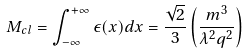<formula> <loc_0><loc_0><loc_500><loc_500>M _ { c l } = \int _ { - \infty } ^ { + \infty } \epsilon ( x ) d x = \frac { \sqrt { 2 } } { 3 } \left ( \frac { m ^ { 3 } } { \lambda ^ { 2 } q ^ { 2 } } \right )</formula> 